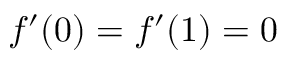<formula> <loc_0><loc_0><loc_500><loc_500>f ^ { \prime } ( 0 ) = f ^ { \prime } ( 1 ) = 0</formula> 